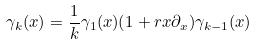<formula> <loc_0><loc_0><loc_500><loc_500>\gamma _ { k } ( x ) = \frac { 1 } { k } \gamma _ { 1 } ( x ) ( 1 + r x \partial _ { x } ) \gamma _ { k - 1 } ( x )</formula> 